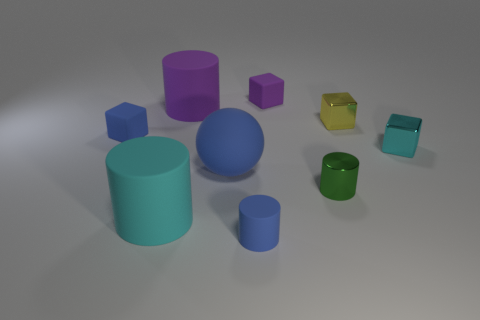Subtract all tiny purple blocks. How many blocks are left? 3 Subtract all green cylinders. How many cylinders are left? 3 Subtract all cylinders. How many objects are left? 5 Subtract 1 cylinders. How many cylinders are left? 3 Subtract 0 brown spheres. How many objects are left? 9 Subtract all gray cubes. Subtract all blue spheres. How many cubes are left? 4 Subtract all red blocks. How many purple cylinders are left? 1 Subtract all matte spheres. Subtract all matte cylinders. How many objects are left? 5 Add 2 blue blocks. How many blue blocks are left? 3 Add 9 big red matte cylinders. How many big red matte cylinders exist? 9 